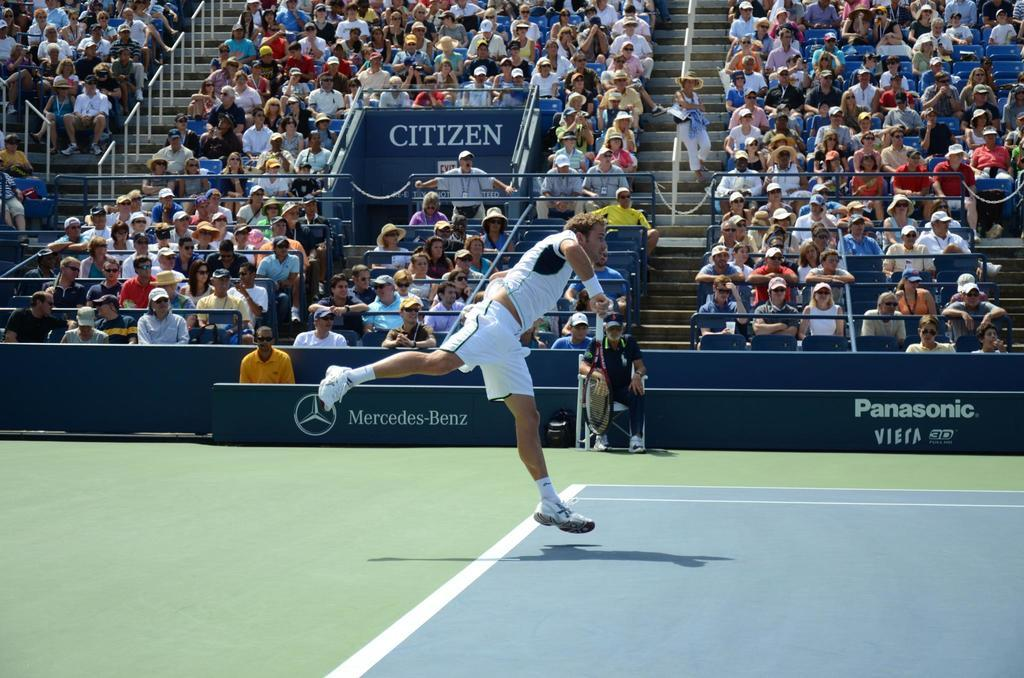Who is the main subject in the image? There is a man in the image. What is the man doing in the image? The man is throwing something. Who is observing the man's actions in the image? There is an audience in the image, and they are watching the man. What can be seen on the wall in the image? There is text on the wall that says "Panasonic Mercedes Benz." What type of cover is the man using to protect himself while driving in the image? There is no mention of driving or a cover in the image; the man is throwing something while an audience watches. 